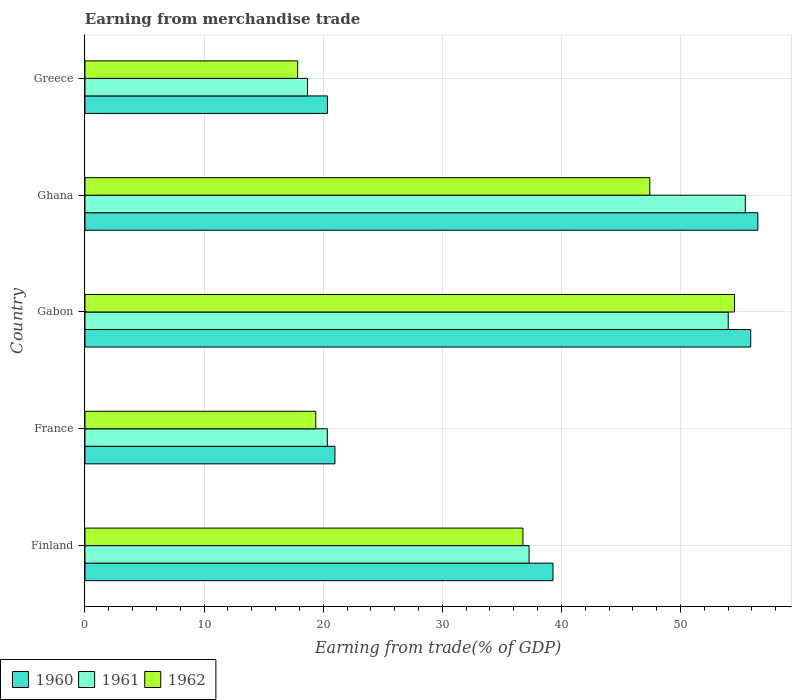How many different coloured bars are there?
Give a very brief answer. 3. How many groups of bars are there?
Provide a succinct answer. 5. Are the number of bars per tick equal to the number of legend labels?
Keep it short and to the point. Yes. How many bars are there on the 1st tick from the bottom?
Keep it short and to the point. 3. What is the label of the 5th group of bars from the top?
Ensure brevity in your answer.  Finland. In how many cases, is the number of bars for a given country not equal to the number of legend labels?
Keep it short and to the point. 0. What is the earnings from trade in 1960 in Ghana?
Provide a succinct answer. 56.5. Across all countries, what is the maximum earnings from trade in 1961?
Keep it short and to the point. 55.44. Across all countries, what is the minimum earnings from trade in 1961?
Provide a short and direct response. 18.69. In which country was the earnings from trade in 1962 maximum?
Your answer should be very brief. Gabon. In which country was the earnings from trade in 1962 minimum?
Offer a terse response. Greece. What is the total earnings from trade in 1961 in the graph?
Keep it short and to the point. 185.78. What is the difference between the earnings from trade in 1960 in Finland and that in Gabon?
Your answer should be compact. -16.6. What is the difference between the earnings from trade in 1962 in Gabon and the earnings from trade in 1960 in Finland?
Your answer should be compact. 15.24. What is the average earnings from trade in 1960 per country?
Ensure brevity in your answer.  38.61. What is the difference between the earnings from trade in 1960 and earnings from trade in 1961 in Gabon?
Your answer should be compact. 1.89. In how many countries, is the earnings from trade in 1960 greater than 28 %?
Provide a short and direct response. 3. What is the ratio of the earnings from trade in 1961 in Finland to that in France?
Give a very brief answer. 1.83. Is the earnings from trade in 1962 in Finland less than that in Ghana?
Give a very brief answer. Yes. What is the difference between the highest and the second highest earnings from trade in 1961?
Keep it short and to the point. 1.44. What is the difference between the highest and the lowest earnings from trade in 1960?
Give a very brief answer. 36.14. In how many countries, is the earnings from trade in 1961 greater than the average earnings from trade in 1961 taken over all countries?
Offer a terse response. 3. Is the sum of the earnings from trade in 1961 in France and Greece greater than the maximum earnings from trade in 1962 across all countries?
Make the answer very short. No. What does the 3rd bar from the top in Greece represents?
Your answer should be very brief. 1960. How many bars are there?
Keep it short and to the point. 15. Are all the bars in the graph horizontal?
Your answer should be very brief. Yes. Does the graph contain any zero values?
Provide a succinct answer. No. Does the graph contain grids?
Provide a succinct answer. Yes. What is the title of the graph?
Offer a very short reply. Earning from merchandise trade. What is the label or title of the X-axis?
Your answer should be compact. Earning from trade(% of GDP). What is the label or title of the Y-axis?
Offer a very short reply. Country. What is the Earning from trade(% of GDP) of 1960 in Finland?
Give a very brief answer. 39.29. What is the Earning from trade(% of GDP) in 1961 in Finland?
Offer a terse response. 37.29. What is the Earning from trade(% of GDP) of 1962 in Finland?
Ensure brevity in your answer.  36.77. What is the Earning from trade(% of GDP) of 1960 in France?
Ensure brevity in your answer.  20.99. What is the Earning from trade(% of GDP) in 1961 in France?
Your response must be concise. 20.35. What is the Earning from trade(% of GDP) in 1962 in France?
Provide a short and direct response. 19.38. What is the Earning from trade(% of GDP) of 1960 in Gabon?
Offer a very short reply. 55.9. What is the Earning from trade(% of GDP) of 1961 in Gabon?
Your response must be concise. 54.01. What is the Earning from trade(% of GDP) in 1962 in Gabon?
Offer a terse response. 54.54. What is the Earning from trade(% of GDP) of 1960 in Ghana?
Provide a short and direct response. 56.5. What is the Earning from trade(% of GDP) of 1961 in Ghana?
Offer a terse response. 55.44. What is the Earning from trade(% of GDP) of 1962 in Ghana?
Your answer should be compact. 47.42. What is the Earning from trade(% of GDP) of 1960 in Greece?
Your response must be concise. 20.36. What is the Earning from trade(% of GDP) in 1961 in Greece?
Offer a very short reply. 18.69. What is the Earning from trade(% of GDP) of 1962 in Greece?
Offer a very short reply. 17.86. Across all countries, what is the maximum Earning from trade(% of GDP) of 1960?
Offer a very short reply. 56.5. Across all countries, what is the maximum Earning from trade(% of GDP) of 1961?
Your answer should be very brief. 55.44. Across all countries, what is the maximum Earning from trade(% of GDP) in 1962?
Offer a very short reply. 54.54. Across all countries, what is the minimum Earning from trade(% of GDP) of 1960?
Provide a short and direct response. 20.36. Across all countries, what is the minimum Earning from trade(% of GDP) in 1961?
Make the answer very short. 18.69. Across all countries, what is the minimum Earning from trade(% of GDP) in 1962?
Your answer should be compact. 17.86. What is the total Earning from trade(% of GDP) in 1960 in the graph?
Ensure brevity in your answer.  193.03. What is the total Earning from trade(% of GDP) in 1961 in the graph?
Provide a succinct answer. 185.78. What is the total Earning from trade(% of GDP) of 1962 in the graph?
Offer a terse response. 175.97. What is the difference between the Earning from trade(% of GDP) in 1960 in Finland and that in France?
Your answer should be very brief. 18.31. What is the difference between the Earning from trade(% of GDP) of 1961 in Finland and that in France?
Offer a very short reply. 16.94. What is the difference between the Earning from trade(% of GDP) in 1962 in Finland and that in France?
Keep it short and to the point. 17.39. What is the difference between the Earning from trade(% of GDP) of 1960 in Finland and that in Gabon?
Your answer should be compact. -16.6. What is the difference between the Earning from trade(% of GDP) of 1961 in Finland and that in Gabon?
Offer a terse response. -16.72. What is the difference between the Earning from trade(% of GDP) in 1962 in Finland and that in Gabon?
Your answer should be compact. -17.77. What is the difference between the Earning from trade(% of GDP) of 1960 in Finland and that in Ghana?
Your response must be concise. -17.2. What is the difference between the Earning from trade(% of GDP) of 1961 in Finland and that in Ghana?
Keep it short and to the point. -18.16. What is the difference between the Earning from trade(% of GDP) of 1962 in Finland and that in Ghana?
Give a very brief answer. -10.65. What is the difference between the Earning from trade(% of GDP) of 1960 in Finland and that in Greece?
Ensure brevity in your answer.  18.94. What is the difference between the Earning from trade(% of GDP) in 1961 in Finland and that in Greece?
Your response must be concise. 18.6. What is the difference between the Earning from trade(% of GDP) of 1962 in Finland and that in Greece?
Offer a terse response. 18.92. What is the difference between the Earning from trade(% of GDP) of 1960 in France and that in Gabon?
Your answer should be compact. -34.91. What is the difference between the Earning from trade(% of GDP) in 1961 in France and that in Gabon?
Make the answer very short. -33.66. What is the difference between the Earning from trade(% of GDP) in 1962 in France and that in Gabon?
Provide a short and direct response. -35.16. What is the difference between the Earning from trade(% of GDP) of 1960 in France and that in Ghana?
Ensure brevity in your answer.  -35.51. What is the difference between the Earning from trade(% of GDP) in 1961 in France and that in Ghana?
Your answer should be compact. -35.1. What is the difference between the Earning from trade(% of GDP) in 1962 in France and that in Ghana?
Keep it short and to the point. -28.04. What is the difference between the Earning from trade(% of GDP) of 1960 in France and that in Greece?
Provide a short and direct response. 0.63. What is the difference between the Earning from trade(% of GDP) of 1961 in France and that in Greece?
Offer a very short reply. 1.66. What is the difference between the Earning from trade(% of GDP) of 1962 in France and that in Greece?
Your response must be concise. 1.52. What is the difference between the Earning from trade(% of GDP) of 1960 in Gabon and that in Ghana?
Provide a succinct answer. -0.6. What is the difference between the Earning from trade(% of GDP) in 1961 in Gabon and that in Ghana?
Provide a succinct answer. -1.44. What is the difference between the Earning from trade(% of GDP) of 1962 in Gabon and that in Ghana?
Provide a succinct answer. 7.12. What is the difference between the Earning from trade(% of GDP) of 1960 in Gabon and that in Greece?
Provide a short and direct response. 35.54. What is the difference between the Earning from trade(% of GDP) in 1961 in Gabon and that in Greece?
Offer a terse response. 35.32. What is the difference between the Earning from trade(% of GDP) of 1962 in Gabon and that in Greece?
Your response must be concise. 36.68. What is the difference between the Earning from trade(% of GDP) of 1960 in Ghana and that in Greece?
Offer a very short reply. 36.14. What is the difference between the Earning from trade(% of GDP) in 1961 in Ghana and that in Greece?
Keep it short and to the point. 36.76. What is the difference between the Earning from trade(% of GDP) in 1962 in Ghana and that in Greece?
Ensure brevity in your answer.  29.57. What is the difference between the Earning from trade(% of GDP) of 1960 in Finland and the Earning from trade(% of GDP) of 1961 in France?
Your response must be concise. 18.95. What is the difference between the Earning from trade(% of GDP) in 1960 in Finland and the Earning from trade(% of GDP) in 1962 in France?
Make the answer very short. 19.91. What is the difference between the Earning from trade(% of GDP) of 1961 in Finland and the Earning from trade(% of GDP) of 1962 in France?
Your answer should be very brief. 17.91. What is the difference between the Earning from trade(% of GDP) in 1960 in Finland and the Earning from trade(% of GDP) in 1961 in Gabon?
Your answer should be very brief. -14.71. What is the difference between the Earning from trade(% of GDP) in 1960 in Finland and the Earning from trade(% of GDP) in 1962 in Gabon?
Offer a terse response. -15.24. What is the difference between the Earning from trade(% of GDP) of 1961 in Finland and the Earning from trade(% of GDP) of 1962 in Gabon?
Ensure brevity in your answer.  -17.25. What is the difference between the Earning from trade(% of GDP) of 1960 in Finland and the Earning from trade(% of GDP) of 1961 in Ghana?
Offer a terse response. -16.15. What is the difference between the Earning from trade(% of GDP) in 1960 in Finland and the Earning from trade(% of GDP) in 1962 in Ghana?
Keep it short and to the point. -8.13. What is the difference between the Earning from trade(% of GDP) in 1961 in Finland and the Earning from trade(% of GDP) in 1962 in Ghana?
Offer a terse response. -10.13. What is the difference between the Earning from trade(% of GDP) of 1960 in Finland and the Earning from trade(% of GDP) of 1961 in Greece?
Keep it short and to the point. 20.61. What is the difference between the Earning from trade(% of GDP) in 1960 in Finland and the Earning from trade(% of GDP) in 1962 in Greece?
Offer a terse response. 21.44. What is the difference between the Earning from trade(% of GDP) in 1961 in Finland and the Earning from trade(% of GDP) in 1962 in Greece?
Your answer should be very brief. 19.43. What is the difference between the Earning from trade(% of GDP) of 1960 in France and the Earning from trade(% of GDP) of 1961 in Gabon?
Provide a succinct answer. -33.02. What is the difference between the Earning from trade(% of GDP) in 1960 in France and the Earning from trade(% of GDP) in 1962 in Gabon?
Your answer should be very brief. -33.55. What is the difference between the Earning from trade(% of GDP) of 1961 in France and the Earning from trade(% of GDP) of 1962 in Gabon?
Ensure brevity in your answer.  -34.19. What is the difference between the Earning from trade(% of GDP) in 1960 in France and the Earning from trade(% of GDP) in 1961 in Ghana?
Ensure brevity in your answer.  -34.46. What is the difference between the Earning from trade(% of GDP) of 1960 in France and the Earning from trade(% of GDP) of 1962 in Ghana?
Provide a succinct answer. -26.43. What is the difference between the Earning from trade(% of GDP) of 1961 in France and the Earning from trade(% of GDP) of 1962 in Ghana?
Provide a short and direct response. -27.07. What is the difference between the Earning from trade(% of GDP) of 1960 in France and the Earning from trade(% of GDP) of 1961 in Greece?
Give a very brief answer. 2.3. What is the difference between the Earning from trade(% of GDP) of 1960 in France and the Earning from trade(% of GDP) of 1962 in Greece?
Offer a very short reply. 3.13. What is the difference between the Earning from trade(% of GDP) of 1961 in France and the Earning from trade(% of GDP) of 1962 in Greece?
Your answer should be very brief. 2.49. What is the difference between the Earning from trade(% of GDP) of 1960 in Gabon and the Earning from trade(% of GDP) of 1961 in Ghana?
Offer a terse response. 0.45. What is the difference between the Earning from trade(% of GDP) in 1960 in Gabon and the Earning from trade(% of GDP) in 1962 in Ghana?
Give a very brief answer. 8.47. What is the difference between the Earning from trade(% of GDP) of 1961 in Gabon and the Earning from trade(% of GDP) of 1962 in Ghana?
Your answer should be very brief. 6.59. What is the difference between the Earning from trade(% of GDP) of 1960 in Gabon and the Earning from trade(% of GDP) of 1961 in Greece?
Ensure brevity in your answer.  37.21. What is the difference between the Earning from trade(% of GDP) in 1960 in Gabon and the Earning from trade(% of GDP) in 1962 in Greece?
Provide a short and direct response. 38.04. What is the difference between the Earning from trade(% of GDP) in 1961 in Gabon and the Earning from trade(% of GDP) in 1962 in Greece?
Keep it short and to the point. 36.15. What is the difference between the Earning from trade(% of GDP) of 1960 in Ghana and the Earning from trade(% of GDP) of 1961 in Greece?
Your response must be concise. 37.81. What is the difference between the Earning from trade(% of GDP) in 1960 in Ghana and the Earning from trade(% of GDP) in 1962 in Greece?
Your answer should be compact. 38.64. What is the difference between the Earning from trade(% of GDP) of 1961 in Ghana and the Earning from trade(% of GDP) of 1962 in Greece?
Offer a very short reply. 37.59. What is the average Earning from trade(% of GDP) of 1960 per country?
Offer a very short reply. 38.61. What is the average Earning from trade(% of GDP) in 1961 per country?
Your response must be concise. 37.16. What is the average Earning from trade(% of GDP) of 1962 per country?
Your response must be concise. 35.19. What is the difference between the Earning from trade(% of GDP) in 1960 and Earning from trade(% of GDP) in 1961 in Finland?
Keep it short and to the point. 2.01. What is the difference between the Earning from trade(% of GDP) of 1960 and Earning from trade(% of GDP) of 1962 in Finland?
Your answer should be compact. 2.52. What is the difference between the Earning from trade(% of GDP) of 1961 and Earning from trade(% of GDP) of 1962 in Finland?
Provide a succinct answer. 0.52. What is the difference between the Earning from trade(% of GDP) in 1960 and Earning from trade(% of GDP) in 1961 in France?
Your answer should be compact. 0.64. What is the difference between the Earning from trade(% of GDP) of 1960 and Earning from trade(% of GDP) of 1962 in France?
Keep it short and to the point. 1.61. What is the difference between the Earning from trade(% of GDP) of 1961 and Earning from trade(% of GDP) of 1962 in France?
Offer a terse response. 0.97. What is the difference between the Earning from trade(% of GDP) in 1960 and Earning from trade(% of GDP) in 1961 in Gabon?
Your answer should be compact. 1.89. What is the difference between the Earning from trade(% of GDP) in 1960 and Earning from trade(% of GDP) in 1962 in Gabon?
Your response must be concise. 1.36. What is the difference between the Earning from trade(% of GDP) of 1961 and Earning from trade(% of GDP) of 1962 in Gabon?
Provide a succinct answer. -0.53. What is the difference between the Earning from trade(% of GDP) of 1960 and Earning from trade(% of GDP) of 1961 in Ghana?
Your response must be concise. 1.05. What is the difference between the Earning from trade(% of GDP) in 1960 and Earning from trade(% of GDP) in 1962 in Ghana?
Ensure brevity in your answer.  9.07. What is the difference between the Earning from trade(% of GDP) of 1961 and Earning from trade(% of GDP) of 1962 in Ghana?
Offer a very short reply. 8.02. What is the difference between the Earning from trade(% of GDP) in 1960 and Earning from trade(% of GDP) in 1961 in Greece?
Offer a terse response. 1.67. What is the difference between the Earning from trade(% of GDP) of 1960 and Earning from trade(% of GDP) of 1962 in Greece?
Make the answer very short. 2.5. What is the difference between the Earning from trade(% of GDP) in 1961 and Earning from trade(% of GDP) in 1962 in Greece?
Ensure brevity in your answer.  0.83. What is the ratio of the Earning from trade(% of GDP) in 1960 in Finland to that in France?
Offer a very short reply. 1.87. What is the ratio of the Earning from trade(% of GDP) of 1961 in Finland to that in France?
Ensure brevity in your answer.  1.83. What is the ratio of the Earning from trade(% of GDP) in 1962 in Finland to that in France?
Ensure brevity in your answer.  1.9. What is the ratio of the Earning from trade(% of GDP) in 1960 in Finland to that in Gabon?
Keep it short and to the point. 0.7. What is the ratio of the Earning from trade(% of GDP) in 1961 in Finland to that in Gabon?
Keep it short and to the point. 0.69. What is the ratio of the Earning from trade(% of GDP) in 1962 in Finland to that in Gabon?
Provide a short and direct response. 0.67. What is the ratio of the Earning from trade(% of GDP) of 1960 in Finland to that in Ghana?
Your response must be concise. 0.7. What is the ratio of the Earning from trade(% of GDP) in 1961 in Finland to that in Ghana?
Give a very brief answer. 0.67. What is the ratio of the Earning from trade(% of GDP) of 1962 in Finland to that in Ghana?
Make the answer very short. 0.78. What is the ratio of the Earning from trade(% of GDP) in 1960 in Finland to that in Greece?
Provide a short and direct response. 1.93. What is the ratio of the Earning from trade(% of GDP) in 1961 in Finland to that in Greece?
Your answer should be very brief. 2. What is the ratio of the Earning from trade(% of GDP) of 1962 in Finland to that in Greece?
Keep it short and to the point. 2.06. What is the ratio of the Earning from trade(% of GDP) of 1960 in France to that in Gabon?
Your answer should be compact. 0.38. What is the ratio of the Earning from trade(% of GDP) of 1961 in France to that in Gabon?
Your answer should be compact. 0.38. What is the ratio of the Earning from trade(% of GDP) of 1962 in France to that in Gabon?
Keep it short and to the point. 0.36. What is the ratio of the Earning from trade(% of GDP) in 1960 in France to that in Ghana?
Make the answer very short. 0.37. What is the ratio of the Earning from trade(% of GDP) in 1961 in France to that in Ghana?
Ensure brevity in your answer.  0.37. What is the ratio of the Earning from trade(% of GDP) of 1962 in France to that in Ghana?
Offer a terse response. 0.41. What is the ratio of the Earning from trade(% of GDP) of 1960 in France to that in Greece?
Ensure brevity in your answer.  1.03. What is the ratio of the Earning from trade(% of GDP) of 1961 in France to that in Greece?
Provide a short and direct response. 1.09. What is the ratio of the Earning from trade(% of GDP) of 1962 in France to that in Greece?
Give a very brief answer. 1.09. What is the ratio of the Earning from trade(% of GDP) of 1960 in Gabon to that in Ghana?
Make the answer very short. 0.99. What is the ratio of the Earning from trade(% of GDP) of 1961 in Gabon to that in Ghana?
Your answer should be compact. 0.97. What is the ratio of the Earning from trade(% of GDP) in 1962 in Gabon to that in Ghana?
Make the answer very short. 1.15. What is the ratio of the Earning from trade(% of GDP) of 1960 in Gabon to that in Greece?
Give a very brief answer. 2.75. What is the ratio of the Earning from trade(% of GDP) of 1961 in Gabon to that in Greece?
Make the answer very short. 2.89. What is the ratio of the Earning from trade(% of GDP) in 1962 in Gabon to that in Greece?
Provide a succinct answer. 3.05. What is the ratio of the Earning from trade(% of GDP) of 1960 in Ghana to that in Greece?
Ensure brevity in your answer.  2.78. What is the ratio of the Earning from trade(% of GDP) of 1961 in Ghana to that in Greece?
Your answer should be compact. 2.97. What is the ratio of the Earning from trade(% of GDP) in 1962 in Ghana to that in Greece?
Offer a very short reply. 2.66. What is the difference between the highest and the second highest Earning from trade(% of GDP) of 1960?
Make the answer very short. 0.6. What is the difference between the highest and the second highest Earning from trade(% of GDP) in 1961?
Offer a terse response. 1.44. What is the difference between the highest and the second highest Earning from trade(% of GDP) in 1962?
Make the answer very short. 7.12. What is the difference between the highest and the lowest Earning from trade(% of GDP) of 1960?
Ensure brevity in your answer.  36.14. What is the difference between the highest and the lowest Earning from trade(% of GDP) in 1961?
Your response must be concise. 36.76. What is the difference between the highest and the lowest Earning from trade(% of GDP) of 1962?
Provide a succinct answer. 36.68. 